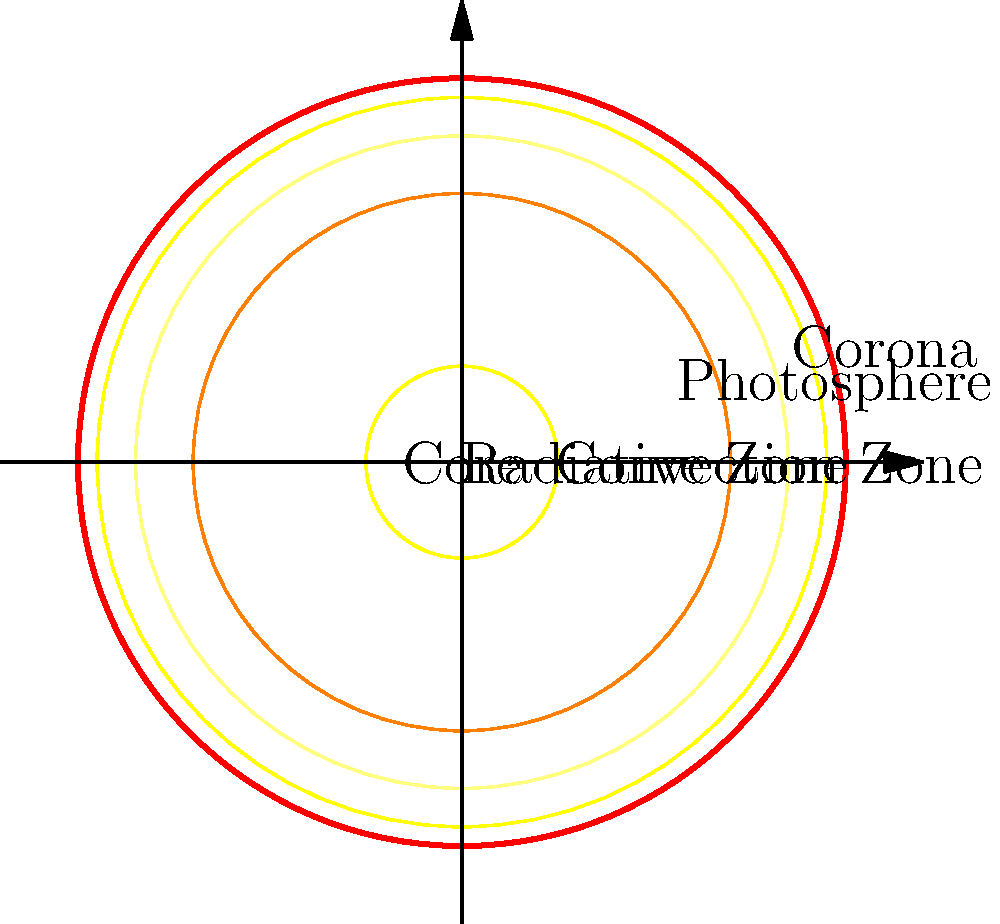As a psychotherapist who recognizes the importance of understanding complex systems, consider the structure of the Sun. Which layer of the Sun is responsible for energy transfer primarily through the movement of plasma, and how might this relate to the concept of transference in psychotherapy? To answer this question, let's break down the structure of the Sun and relate it to psychotherapeutic concepts:

1. The Sun's structure, from the inside out, consists of:
   a) Core
   b) Radiative Zone
   c) Convection Zone
   d) Photosphere
   e) Corona

2. The Convection Zone is the layer responsible for energy transfer primarily through the movement of plasma. This occurs because:
   a) The temperature gradient in this region is steep enough to cause convection.
   b) Hot plasma rises, cools, and then sinks, creating a cyclic motion.

3. Relating this to transference in psychotherapy:
   a) Transference is the unconscious redirection of feelings from one person to another, often from patient to therapist.
   b) Like the convection currents in the Sun, emotions and past experiences "rise" from the patient's unconscious and are "transferred" to the therapeutic relationship.
   c) The therapist, like the cooler outer layers of the Sun, receives these emotions and helps the patient process them.
   d) This cyclical process of emotional expression and processing in therapy mirrors the continuous movement in the Sun's Convection Zone.

4. Both systems involve:
   a) Movement of content (plasma in the Sun, emotions in therapy)
   b) Transfer of energy (heat in the Sun, emotional energy in therapy)
   c) Cyclical processes (convection currents, therapeutic progress)

5. Understanding this analogy can help a psychotherapist explain complex psychological processes to patients, using the familiar structure of the Sun as a metaphor for the layers of the human psyche and the therapeutic process.
Answer: Convection Zone; both involve cyclical transfer of content and energy. 